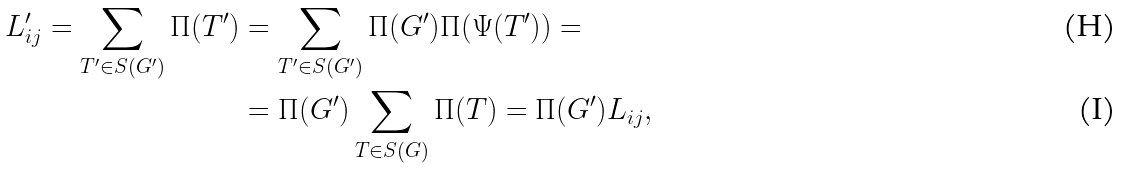<formula> <loc_0><loc_0><loc_500><loc_500>L ^ { \prime } _ { i j } = \sum _ { T ^ { \prime } \in S ( G ^ { \prime } ) } \Pi ( T ^ { \prime } ) & = \sum _ { T ^ { \prime } \in S ( G ^ { \prime } ) } \Pi ( G ^ { \prime } ) \Pi ( \Psi ( T ^ { \prime } ) ) = \\ & = \Pi ( G ^ { \prime } ) \sum _ { T \in S ( G ) } \Pi ( T ) = \Pi ( G ^ { \prime } ) L _ { i j } ,</formula> 